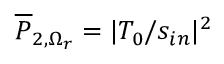Convert formula to latex. <formula><loc_0><loc_0><loc_500><loc_500>\overline { P } _ { 2 , \Omega _ { r } } = | T _ { 0 } / s _ { i n } | ^ { 2 }</formula> 